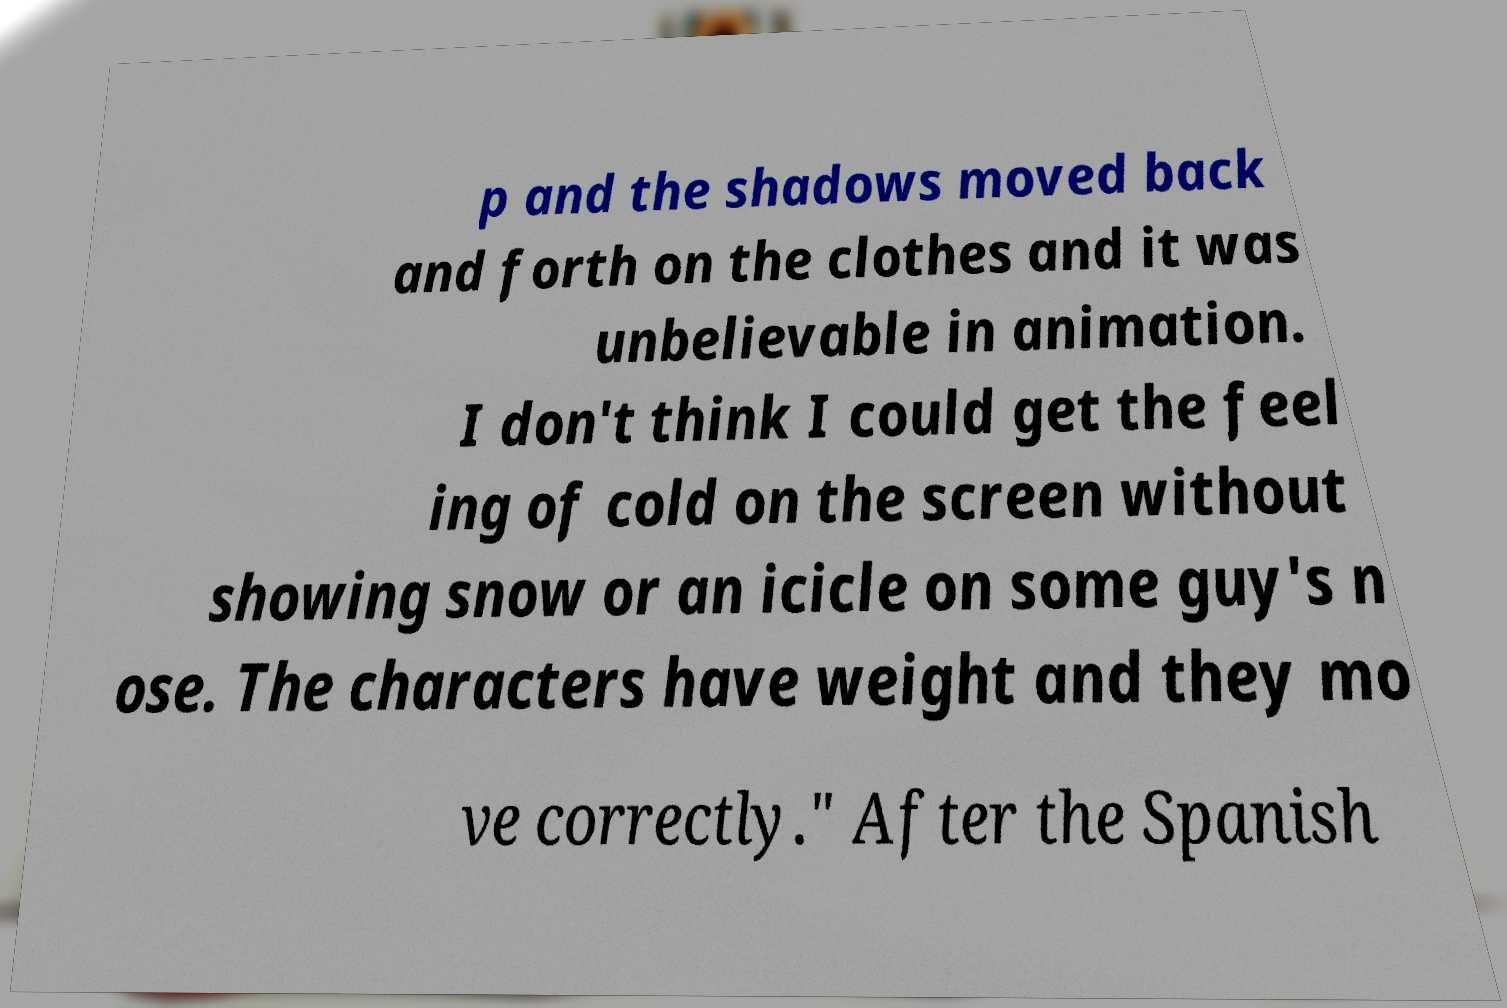Please read and relay the text visible in this image. What does it say? p and the shadows moved back and forth on the clothes and it was unbelievable in animation. I don't think I could get the feel ing of cold on the screen without showing snow or an icicle on some guy's n ose. The characters have weight and they mo ve correctly." After the Spanish 